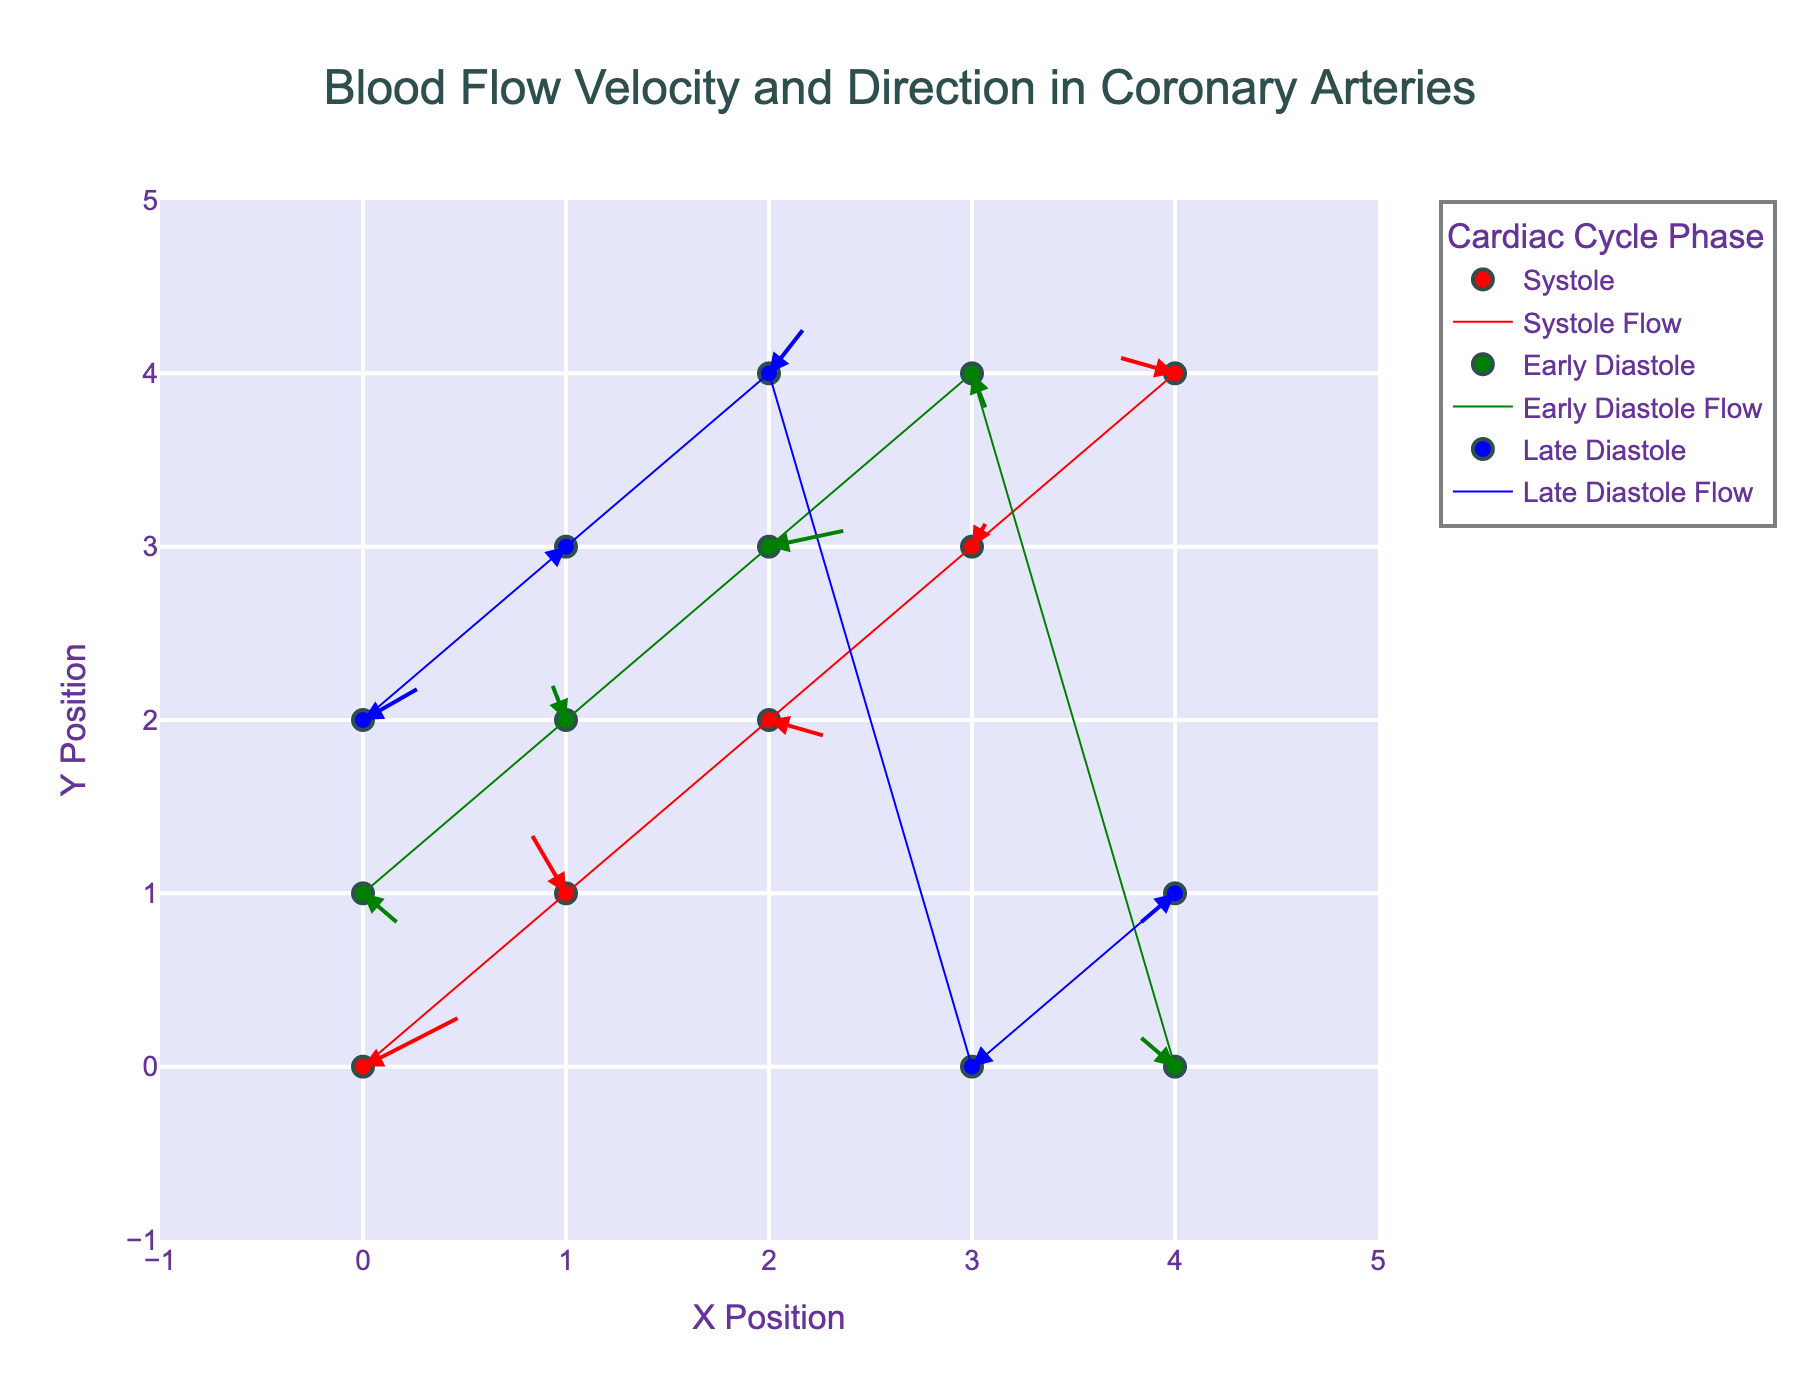How many unique phases are displayed in the plot? The title indicates that the plot is about different phases of the cardiac cycle. By reviewing the legend, we can identify the different phases named in the plot.
Answer: 3 Which phase has the most data points? Count the markers for each phase in the legend to determine which phase has the highest number of displayed points.
Answer: Early Diastole What are the x and y ranges displayed on the axes? Look at the x and y axes to identify the minimum and maximum values shown. The ranges extend from the leftmost to the rightmost mark on the x-axis and the bottommost to the topmost mark on the y-axis.
Answer: -1 to 5 During Late Diastole, what is the direction of blood flow at position (1, 3)? Identify the markers and arrows at position (1, 3) for Late Diastole. Check the arrow direction starting from (1, 3).
Answer: Downward and to the left Compare the direction of blood flow during Early Diastole between the points (0, 1) and (4, 0). Locate the points (0, 1) and (4, 0) on the plot for Early Diastole and observe the direction of the arrows at these positions.
Answer: Opposite directions In which phase does the point (2, 2) lie, and what is the direction and magnitude of blood flow at that point? Determine which phase includes the point (2, 2) by checking the positions and phases. For the directional flow, check both the u and v components specified for that phase. Calculate the magnitude using the Pythagorean theorem (sqrt(u^2 + v^2)).
Answer: Systole, to the right and slightly downward, magnitude 0.32 What is the sum of the v components of blood flow vectors during Early Diastole? Add up the v components of the blood flow vectors for all points in Early Diastole (values are 0.4, -0.3, 0.1, -0.1, 0.2).
Answer: 0.3 Which phase shows blood flow in both the positive and negative x directions? Review all phases and check the arrows' directions along the x-axis, noting which phases contain arrows pointing both rightwards and leftwards.
Answer: All phases What is the average blood flow velocity in the x direction during Systole? Sum up the u components (0.5, -0.2, 0.3, 0.1, -0.3) and divide by the number of data points in Systole.
Answer: 0.08 